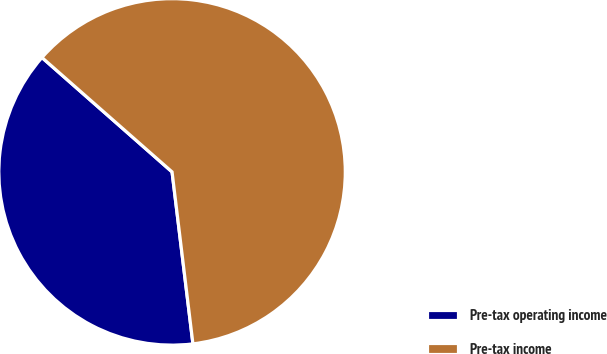Convert chart. <chart><loc_0><loc_0><loc_500><loc_500><pie_chart><fcel>Pre-tax operating income<fcel>Pre-tax income<nl><fcel>38.4%<fcel>61.6%<nl></chart> 